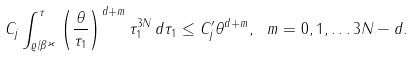Convert formula to latex. <formula><loc_0><loc_0><loc_500><loc_500>C _ { j } \int _ { \varrho / \beta ^ { \varkappa } } ^ { \tau } \left ( \frac { \theta } { \tau _ { 1 } } \right ) ^ { d + m } \tau _ { 1 } ^ { 3 N } \, d \tau _ { 1 } \leq C _ { j } ^ { \prime } \theta ^ { d + m } , \ m = 0 , 1 , \dots 3 N - d .</formula> 